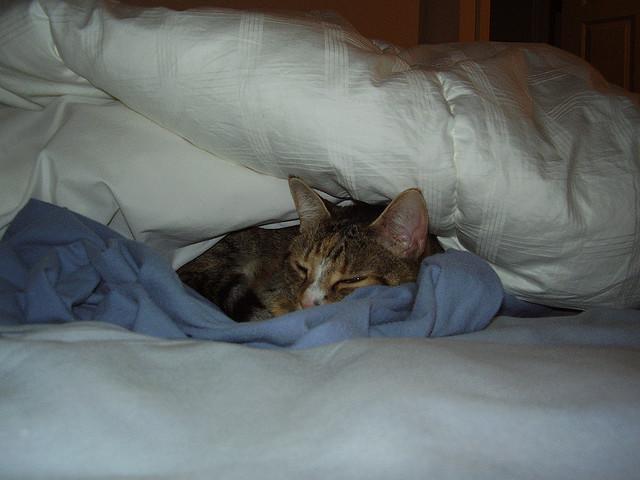How many beds can you see?
Give a very brief answer. 1. How many people are dining?
Give a very brief answer. 0. 